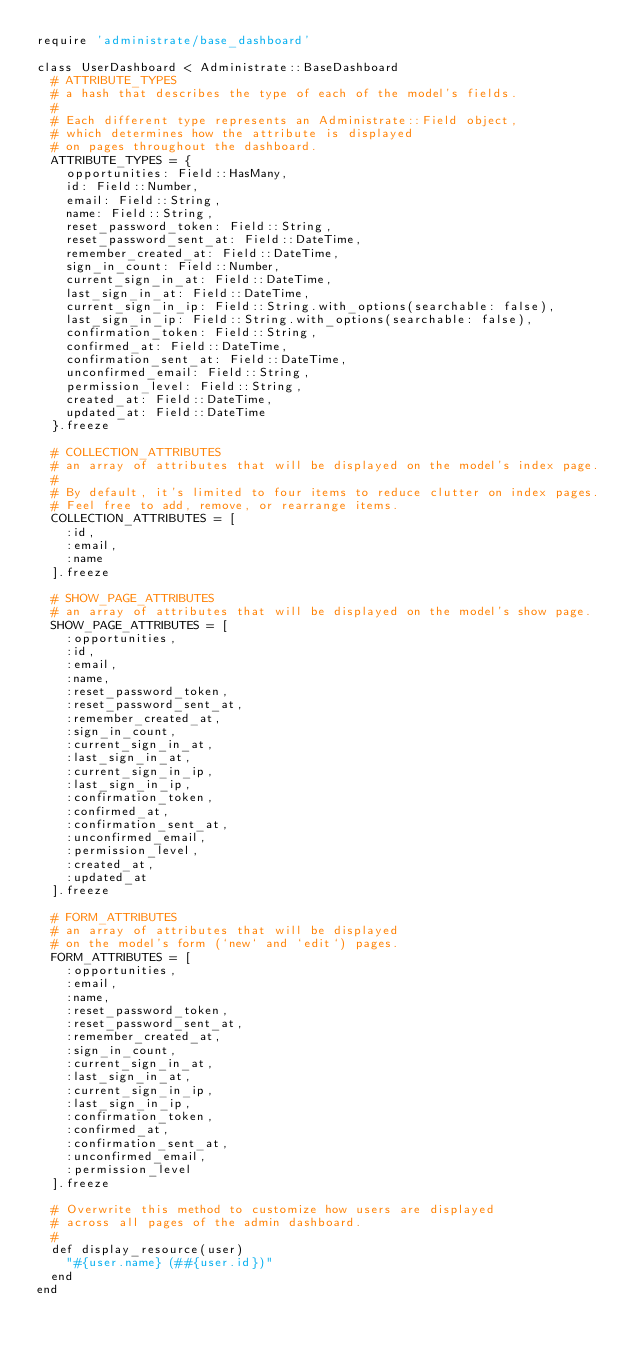Convert code to text. <code><loc_0><loc_0><loc_500><loc_500><_Ruby_>require 'administrate/base_dashboard'

class UserDashboard < Administrate::BaseDashboard
  # ATTRIBUTE_TYPES
  # a hash that describes the type of each of the model's fields.
  #
  # Each different type represents an Administrate::Field object,
  # which determines how the attribute is displayed
  # on pages throughout the dashboard.
  ATTRIBUTE_TYPES = {
    opportunities: Field::HasMany,
    id: Field::Number,
    email: Field::String,
    name: Field::String,
    reset_password_token: Field::String,
    reset_password_sent_at: Field::DateTime,
    remember_created_at: Field::DateTime,
    sign_in_count: Field::Number,
    current_sign_in_at: Field::DateTime,
    last_sign_in_at: Field::DateTime,
    current_sign_in_ip: Field::String.with_options(searchable: false),
    last_sign_in_ip: Field::String.with_options(searchable: false),
    confirmation_token: Field::String,
    confirmed_at: Field::DateTime,
    confirmation_sent_at: Field::DateTime,
    unconfirmed_email: Field::String,
    permission_level: Field::String,
    created_at: Field::DateTime,
    updated_at: Field::DateTime
  }.freeze

  # COLLECTION_ATTRIBUTES
  # an array of attributes that will be displayed on the model's index page.
  #
  # By default, it's limited to four items to reduce clutter on index pages.
  # Feel free to add, remove, or rearrange items.
  COLLECTION_ATTRIBUTES = [
    :id,
    :email,
    :name
  ].freeze

  # SHOW_PAGE_ATTRIBUTES
  # an array of attributes that will be displayed on the model's show page.
  SHOW_PAGE_ATTRIBUTES = [
    :opportunities,
    :id,
    :email,
    :name,
    :reset_password_token,
    :reset_password_sent_at,
    :remember_created_at,
    :sign_in_count,
    :current_sign_in_at,
    :last_sign_in_at,
    :current_sign_in_ip,
    :last_sign_in_ip,
    :confirmation_token,
    :confirmed_at,
    :confirmation_sent_at,
    :unconfirmed_email,
    :permission_level,
    :created_at,
    :updated_at
  ].freeze

  # FORM_ATTRIBUTES
  # an array of attributes that will be displayed
  # on the model's form (`new` and `edit`) pages.
  FORM_ATTRIBUTES = [
    :opportunities,
    :email,
    :name,
    :reset_password_token,
    :reset_password_sent_at,
    :remember_created_at,
    :sign_in_count,
    :current_sign_in_at,
    :last_sign_in_at,
    :current_sign_in_ip,
    :last_sign_in_ip,
    :confirmation_token,
    :confirmed_at,
    :confirmation_sent_at,
    :unconfirmed_email,
    :permission_level
  ].freeze

  # Overwrite this method to customize how users are displayed
  # across all pages of the admin dashboard.
  #
  def display_resource(user)
    "#{user.name} (##{user.id})"
  end
end
</code> 